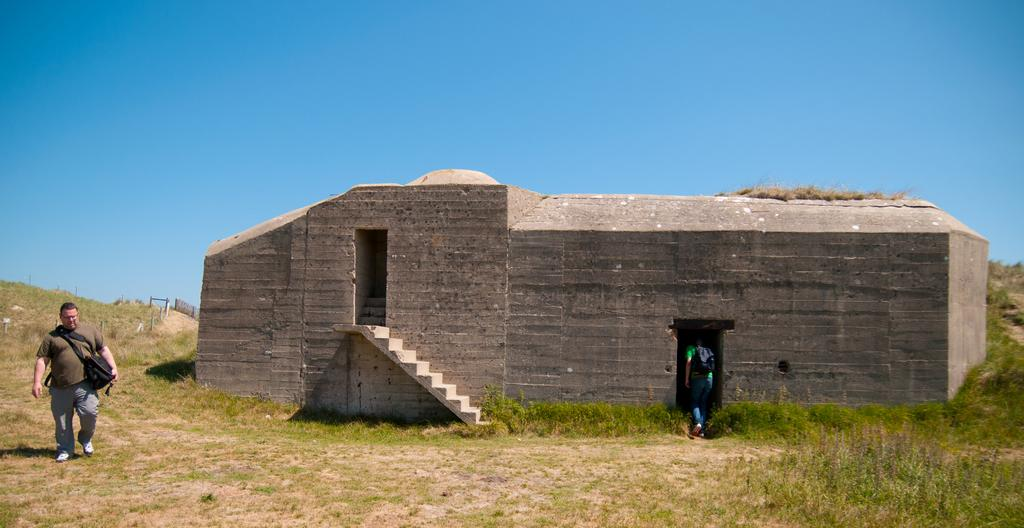What is the main structure in the image? There is a monument in the image. Are there any people present in the image? Yes, there are two people in the image. What type of surface is on the ground in the image? There is grass on the ground in the image. What can be seen in the background of the image? The sky is visible in the background of the image. Where is the sink located in the image? There is no sink present in the image. What type of vegetable is being held by the man in the image? There is no man or vegetable present in the image. 